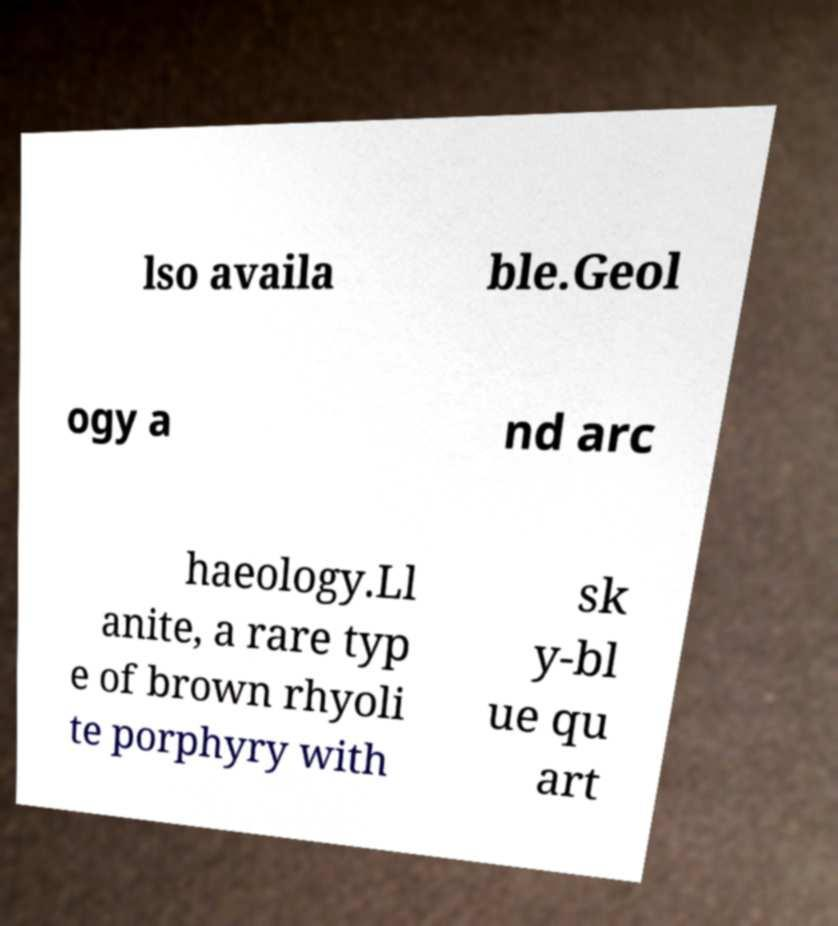Please read and relay the text visible in this image. What does it say? lso availa ble.Geol ogy a nd arc haeology.Ll anite, a rare typ e of brown rhyoli te porphyry with sk y-bl ue qu art 